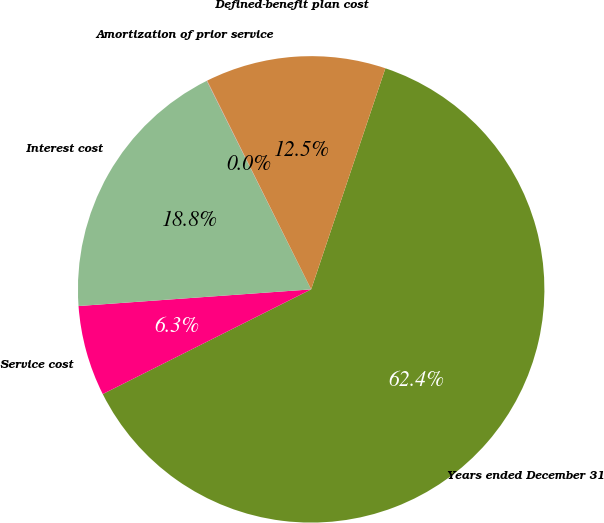Convert chart. <chart><loc_0><loc_0><loc_500><loc_500><pie_chart><fcel>Years ended December 31<fcel>Service cost<fcel>Interest cost<fcel>Amortization of prior service<fcel>Defined-benefit plan cost<nl><fcel>62.43%<fcel>6.27%<fcel>18.75%<fcel>0.03%<fcel>12.51%<nl></chart> 